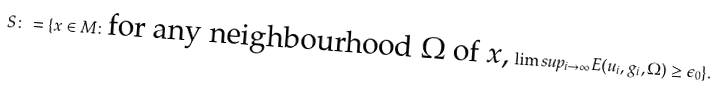<formula> <loc_0><loc_0><loc_500><loc_500>S \colon = \{ x \in M \colon \text {for any neighbourhood $\Omega$ of $x$,} \, \lim s u p _ { i \to \infty } E ( u _ { i } , g _ { i } , \Omega ) \geq \epsilon _ { 0 } \} .</formula> 